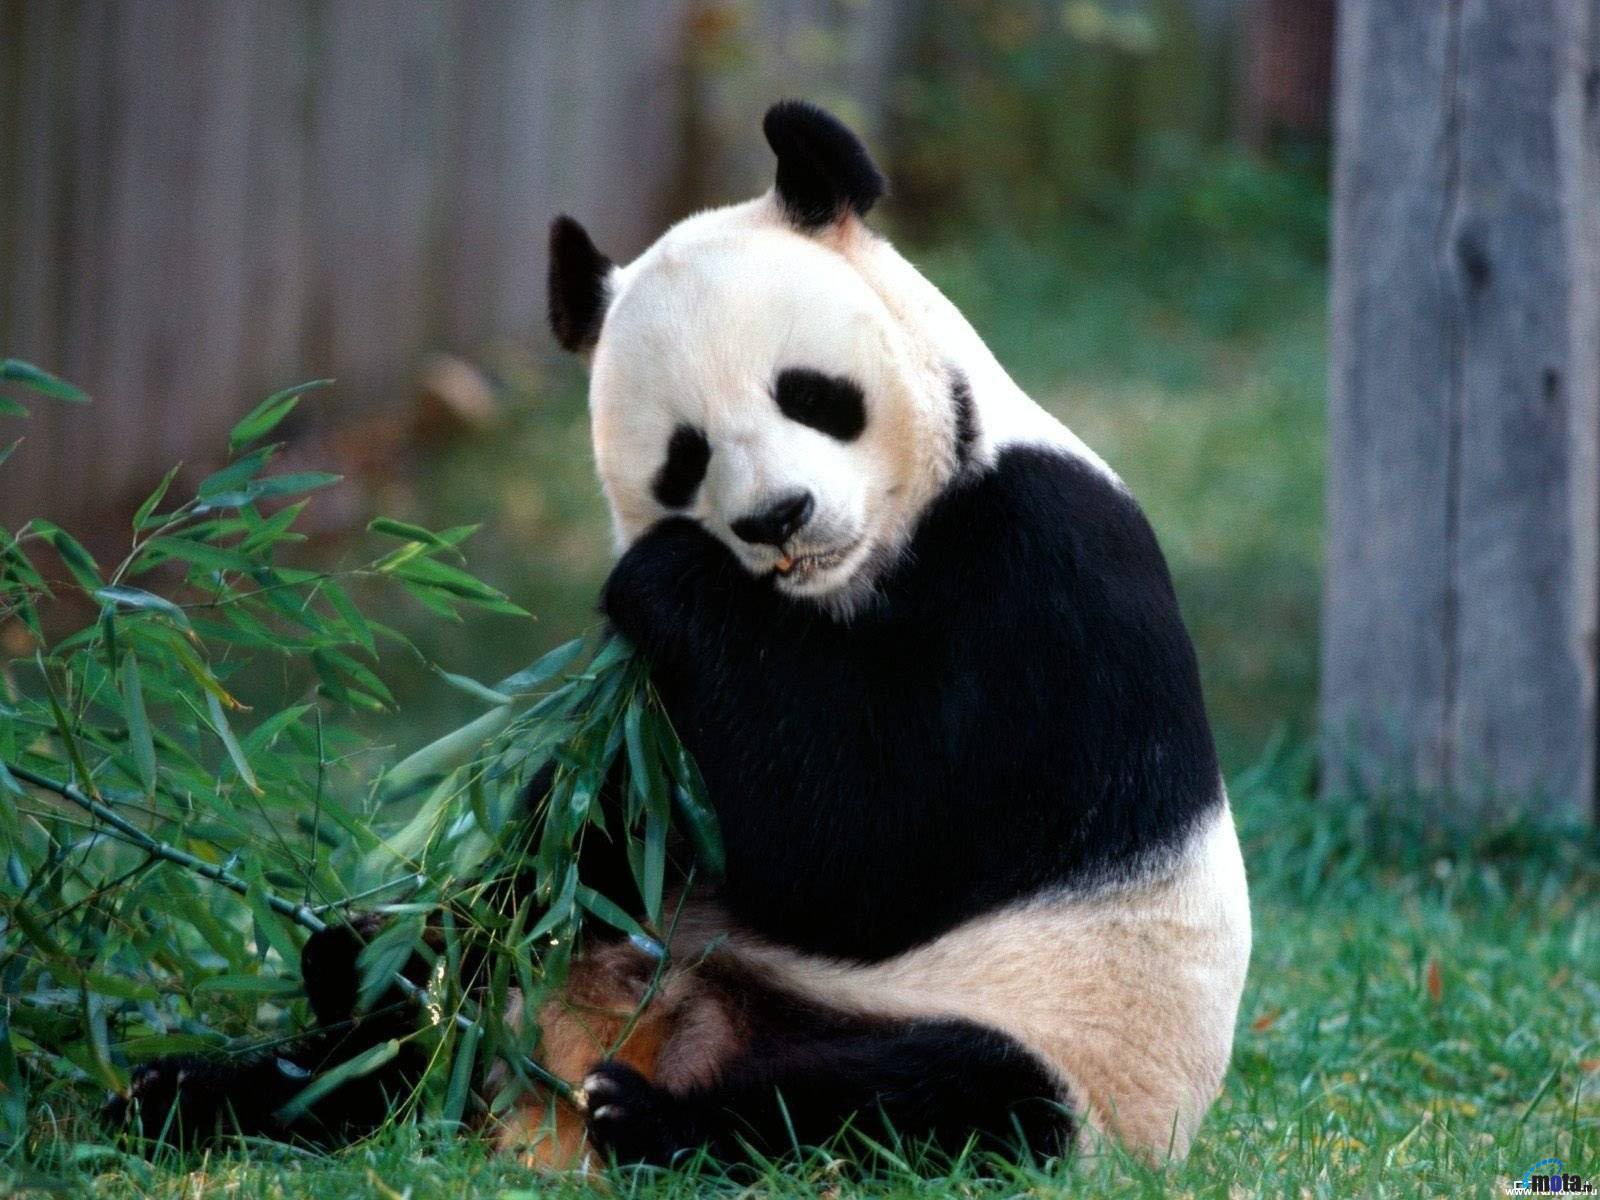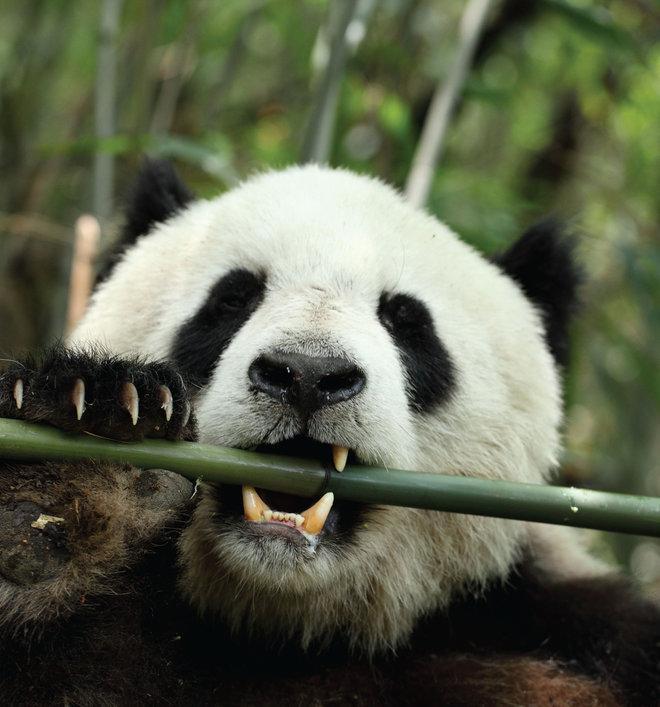The first image is the image on the left, the second image is the image on the right. Assess this claim about the two images: "One panda is munching a single leafless thick green stalk between his exposed upper and lower teeth.". Correct or not? Answer yes or no. Yes. The first image is the image on the left, the second image is the image on the right. For the images shown, is this caption "Each image shows a panda placing bamboo in its mouth." true? Answer yes or no. Yes. 